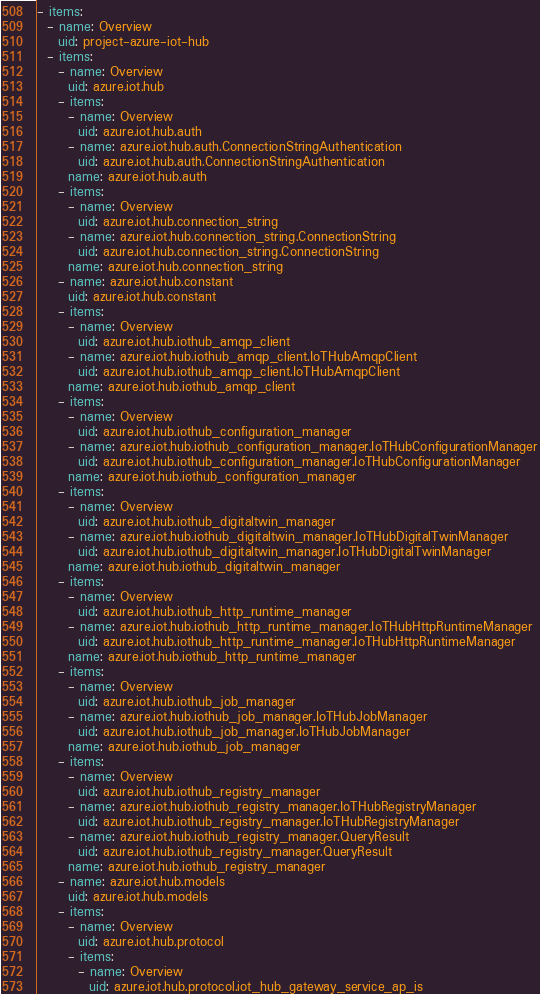<code> <loc_0><loc_0><loc_500><loc_500><_YAML_>- items:
  - name: Overview
    uid: project-azure-iot-hub
  - items:
    - name: Overview
      uid: azure.iot.hub
    - items:
      - name: Overview
        uid: azure.iot.hub.auth
      - name: azure.iot.hub.auth.ConnectionStringAuthentication
        uid: azure.iot.hub.auth.ConnectionStringAuthentication
      name: azure.iot.hub.auth
    - items:
      - name: Overview
        uid: azure.iot.hub.connection_string
      - name: azure.iot.hub.connection_string.ConnectionString
        uid: azure.iot.hub.connection_string.ConnectionString
      name: azure.iot.hub.connection_string
    - name: azure.iot.hub.constant
      uid: azure.iot.hub.constant
    - items:
      - name: Overview
        uid: azure.iot.hub.iothub_amqp_client
      - name: azure.iot.hub.iothub_amqp_client.IoTHubAmqpClient
        uid: azure.iot.hub.iothub_amqp_client.IoTHubAmqpClient
      name: azure.iot.hub.iothub_amqp_client
    - items:
      - name: Overview
        uid: azure.iot.hub.iothub_configuration_manager
      - name: azure.iot.hub.iothub_configuration_manager.IoTHubConfigurationManager
        uid: azure.iot.hub.iothub_configuration_manager.IoTHubConfigurationManager
      name: azure.iot.hub.iothub_configuration_manager
    - items:
      - name: Overview
        uid: azure.iot.hub.iothub_digitaltwin_manager
      - name: azure.iot.hub.iothub_digitaltwin_manager.IoTHubDigitalTwinManager
        uid: azure.iot.hub.iothub_digitaltwin_manager.IoTHubDigitalTwinManager
      name: azure.iot.hub.iothub_digitaltwin_manager
    - items:
      - name: Overview
        uid: azure.iot.hub.iothub_http_runtime_manager
      - name: azure.iot.hub.iothub_http_runtime_manager.IoTHubHttpRuntimeManager
        uid: azure.iot.hub.iothub_http_runtime_manager.IoTHubHttpRuntimeManager
      name: azure.iot.hub.iothub_http_runtime_manager
    - items:
      - name: Overview
        uid: azure.iot.hub.iothub_job_manager
      - name: azure.iot.hub.iothub_job_manager.IoTHubJobManager
        uid: azure.iot.hub.iothub_job_manager.IoTHubJobManager
      name: azure.iot.hub.iothub_job_manager
    - items:
      - name: Overview
        uid: azure.iot.hub.iothub_registry_manager
      - name: azure.iot.hub.iothub_registry_manager.IoTHubRegistryManager
        uid: azure.iot.hub.iothub_registry_manager.IoTHubRegistryManager
      - name: azure.iot.hub.iothub_registry_manager.QueryResult
        uid: azure.iot.hub.iothub_registry_manager.QueryResult
      name: azure.iot.hub.iothub_registry_manager
    - name: azure.iot.hub.models
      uid: azure.iot.hub.models
    - items:
      - name: Overview
        uid: azure.iot.hub.protocol
      - items:
        - name: Overview
          uid: azure.iot.hub.protocol.iot_hub_gateway_service_ap_is</code> 